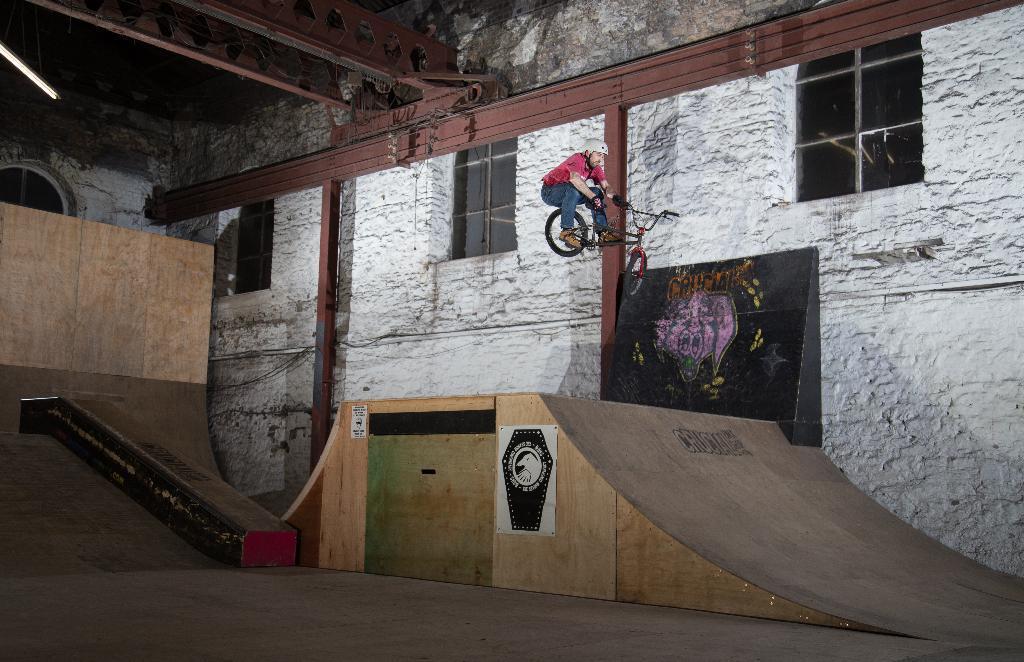Describe this image in one or two sentences. In this image, we can see a man on the bicycle in the air, we can see a slope and there is a white color wall and we can see some windows. 